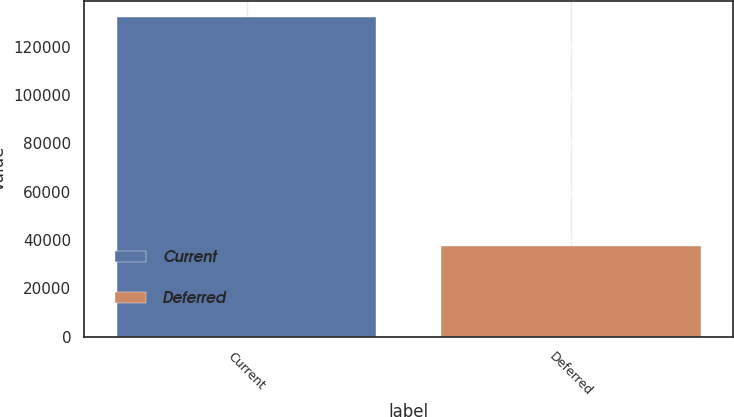Convert chart to OTSL. <chart><loc_0><loc_0><loc_500><loc_500><bar_chart><fcel>Current<fcel>Deferred<nl><fcel>132420<fcel>37316<nl></chart> 